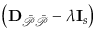<formula> <loc_0><loc_0><loc_500><loc_500>\left ( D _ { \mathcal { \ B a r { P } \ B a r { P } } } - \lambda I _ { s } \right )</formula> 